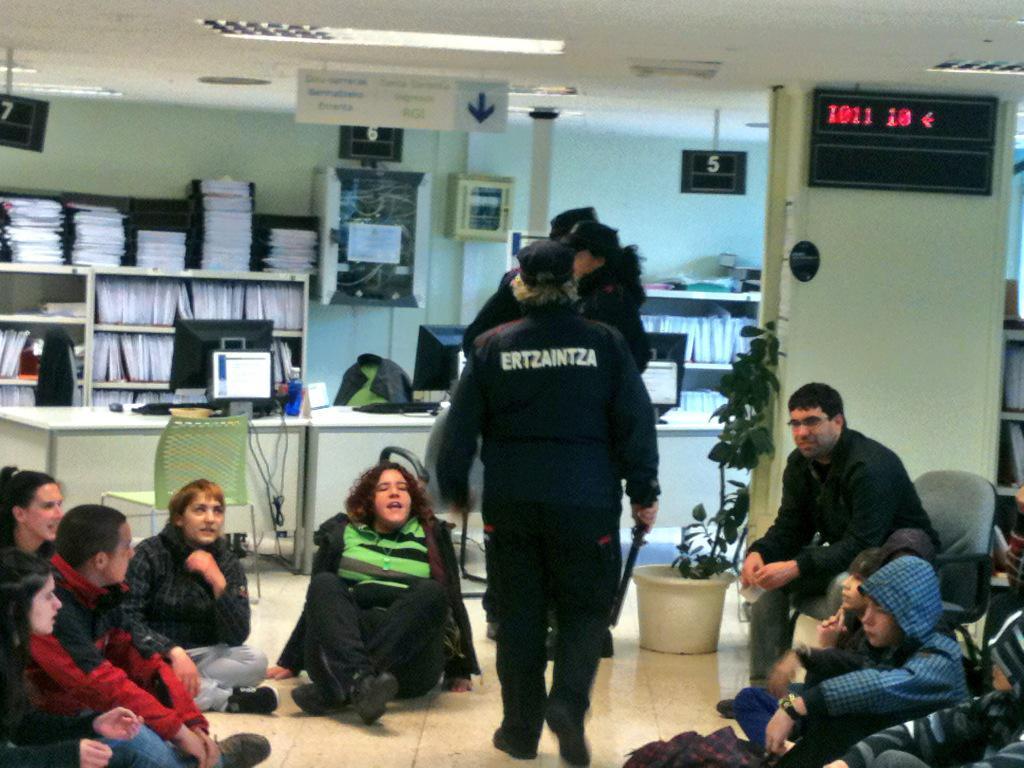Describe this image in one or two sentences. In a room there are a group of people sitting on the floor and some people are standing in between them, on the right side there is a man sitting on the chair and in the background there are a lot of books kept in the shelves and in front of the shelves there is a table and on the table there are computers and on the right side there is a wall behind the man and on the wall there is a screen displaying some numbers, beside that wall there is a plant. 